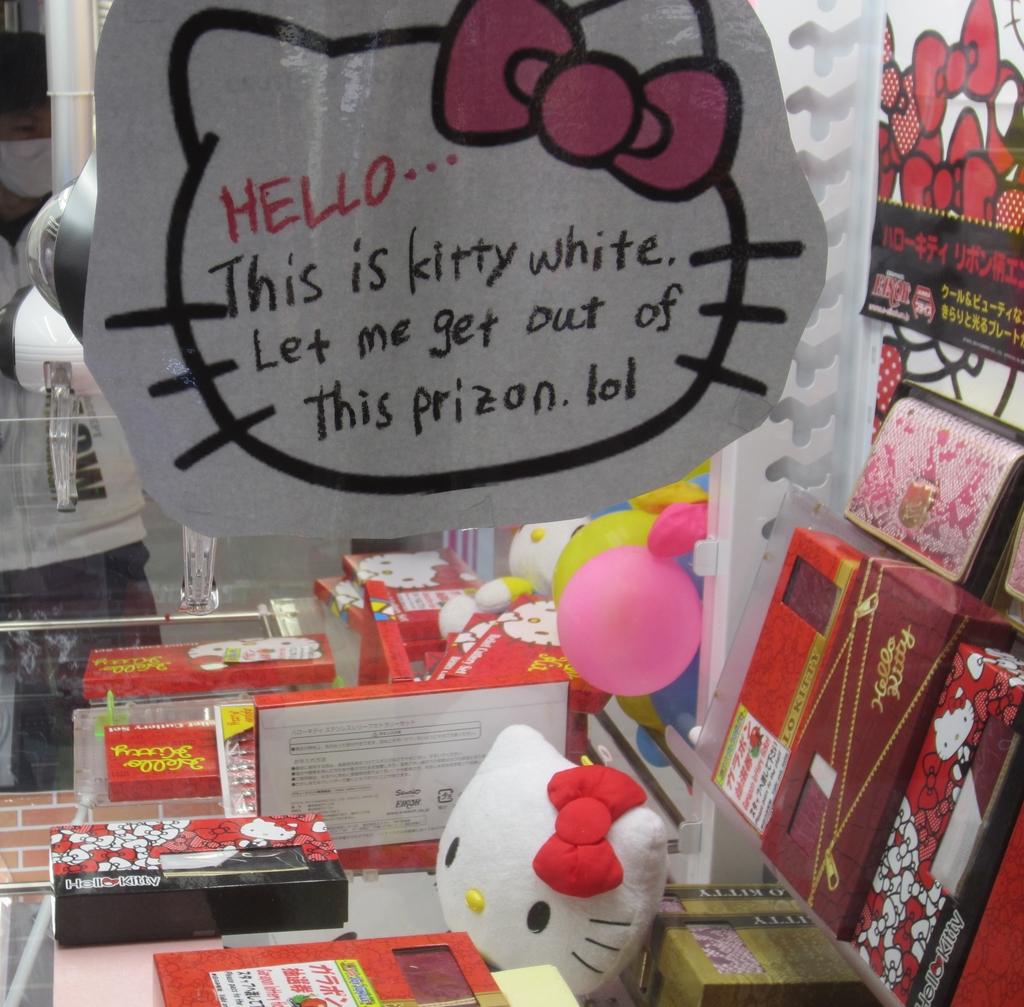What is the top word?
Keep it short and to the point. Hello. 